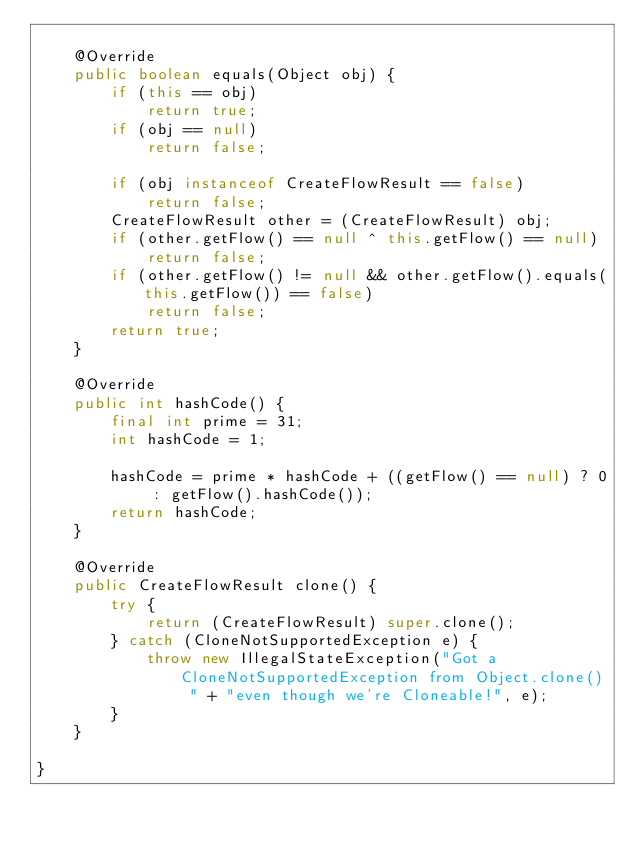Convert code to text. <code><loc_0><loc_0><loc_500><loc_500><_Java_>
    @Override
    public boolean equals(Object obj) {
        if (this == obj)
            return true;
        if (obj == null)
            return false;

        if (obj instanceof CreateFlowResult == false)
            return false;
        CreateFlowResult other = (CreateFlowResult) obj;
        if (other.getFlow() == null ^ this.getFlow() == null)
            return false;
        if (other.getFlow() != null && other.getFlow().equals(this.getFlow()) == false)
            return false;
        return true;
    }

    @Override
    public int hashCode() {
        final int prime = 31;
        int hashCode = 1;

        hashCode = prime * hashCode + ((getFlow() == null) ? 0 : getFlow().hashCode());
        return hashCode;
    }

    @Override
    public CreateFlowResult clone() {
        try {
            return (CreateFlowResult) super.clone();
        } catch (CloneNotSupportedException e) {
            throw new IllegalStateException("Got a CloneNotSupportedException from Object.clone() " + "even though we're Cloneable!", e);
        }
    }

}
</code> 